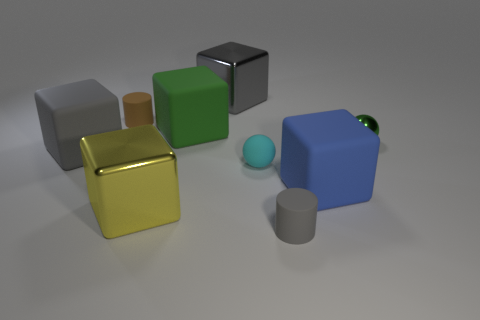Subtract all yellow blocks. How many blocks are left? 4 Subtract all yellow cubes. How many cubes are left? 4 Subtract all cyan cubes. Subtract all purple cylinders. How many cubes are left? 5 Subtract all cylinders. How many objects are left? 7 Subtract all tiny cylinders. Subtract all blue rubber blocks. How many objects are left? 6 Add 9 gray metallic objects. How many gray metallic objects are left? 10 Add 6 large cyan things. How many large cyan things exist? 6 Subtract 2 gray cubes. How many objects are left? 7 